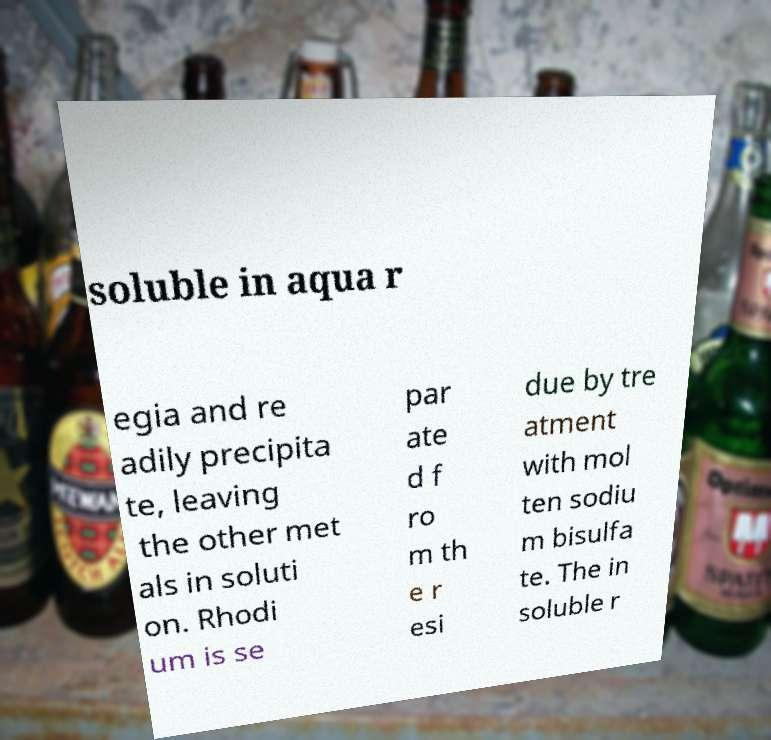I need the written content from this picture converted into text. Can you do that? soluble in aqua r egia and re adily precipita te, leaving the other met als in soluti on. Rhodi um is se par ate d f ro m th e r esi due by tre atment with mol ten sodiu m bisulfa te. The in soluble r 